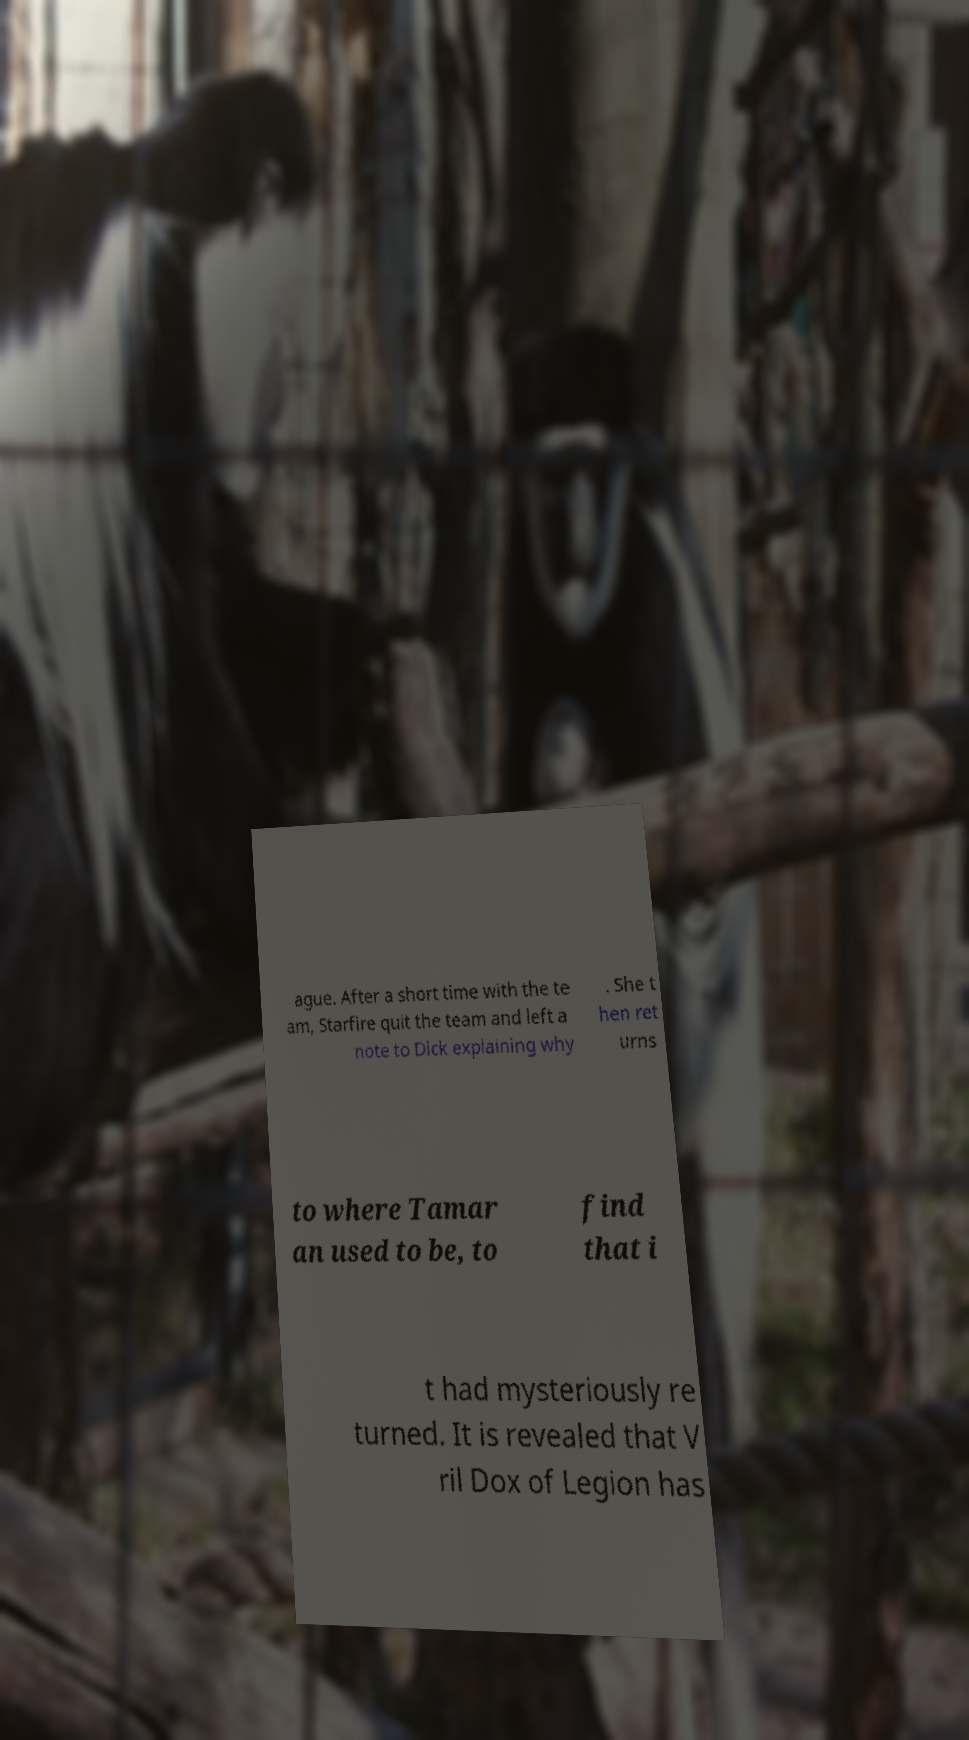Please read and relay the text visible in this image. What does it say? ague. After a short time with the te am, Starfire quit the team and left a note to Dick explaining why . She t hen ret urns to where Tamar an used to be, to find that i t had mysteriously re turned. It is revealed that V ril Dox of Legion has 